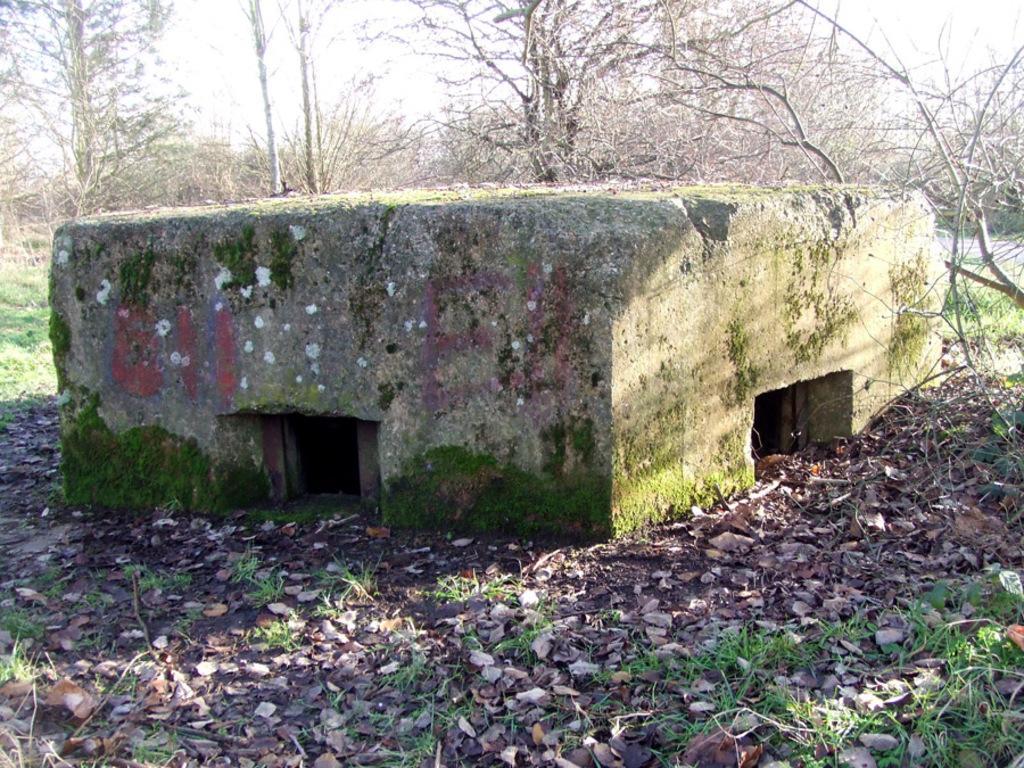Please provide a concise description of this image. In the foreground of this image, there is a cement structure in the middle of the image. In the background, there are trees and the sky. 